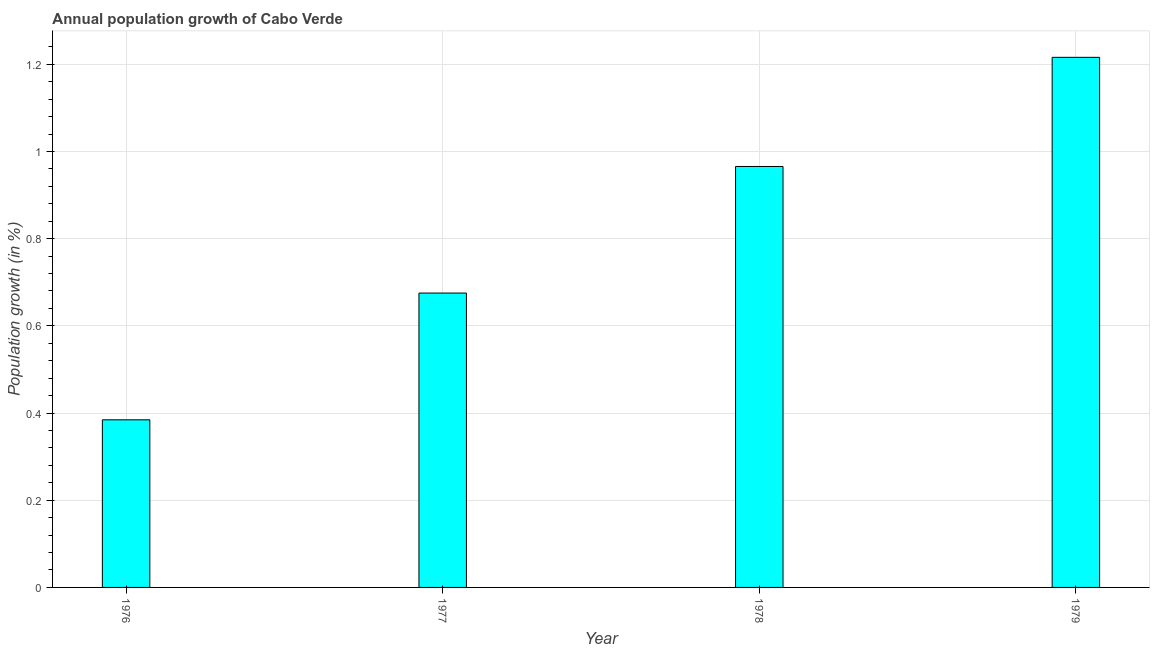Does the graph contain grids?
Offer a terse response. Yes. What is the title of the graph?
Your answer should be compact. Annual population growth of Cabo Verde. What is the label or title of the Y-axis?
Your answer should be very brief. Population growth (in %). What is the population growth in 1979?
Offer a terse response. 1.22. Across all years, what is the maximum population growth?
Provide a short and direct response. 1.22. Across all years, what is the minimum population growth?
Provide a short and direct response. 0.38. In which year was the population growth maximum?
Your answer should be compact. 1979. In which year was the population growth minimum?
Provide a succinct answer. 1976. What is the sum of the population growth?
Keep it short and to the point. 3.24. What is the difference between the population growth in 1976 and 1978?
Your answer should be compact. -0.58. What is the average population growth per year?
Your response must be concise. 0.81. What is the median population growth?
Your answer should be compact. 0.82. In how many years, is the population growth greater than 0.24 %?
Offer a terse response. 4. What is the ratio of the population growth in 1977 to that in 1979?
Keep it short and to the point. 0.56. Is the difference between the population growth in 1978 and 1979 greater than the difference between any two years?
Give a very brief answer. No. Is the sum of the population growth in 1978 and 1979 greater than the maximum population growth across all years?
Offer a terse response. Yes. What is the difference between the highest and the lowest population growth?
Keep it short and to the point. 0.83. In how many years, is the population growth greater than the average population growth taken over all years?
Provide a short and direct response. 2. How many bars are there?
Your answer should be very brief. 4. How many years are there in the graph?
Provide a succinct answer. 4. What is the Population growth (in %) of 1976?
Your answer should be compact. 0.38. What is the Population growth (in %) of 1977?
Provide a short and direct response. 0.68. What is the Population growth (in %) in 1978?
Your answer should be compact. 0.97. What is the Population growth (in %) in 1979?
Provide a succinct answer. 1.22. What is the difference between the Population growth (in %) in 1976 and 1977?
Offer a terse response. -0.29. What is the difference between the Population growth (in %) in 1976 and 1978?
Offer a terse response. -0.58. What is the difference between the Population growth (in %) in 1976 and 1979?
Your answer should be very brief. -0.83. What is the difference between the Population growth (in %) in 1977 and 1978?
Your answer should be very brief. -0.29. What is the difference between the Population growth (in %) in 1977 and 1979?
Ensure brevity in your answer.  -0.54. What is the difference between the Population growth (in %) in 1978 and 1979?
Provide a succinct answer. -0.25. What is the ratio of the Population growth (in %) in 1976 to that in 1977?
Offer a very short reply. 0.57. What is the ratio of the Population growth (in %) in 1976 to that in 1978?
Your response must be concise. 0.4. What is the ratio of the Population growth (in %) in 1976 to that in 1979?
Ensure brevity in your answer.  0.32. What is the ratio of the Population growth (in %) in 1977 to that in 1978?
Make the answer very short. 0.7. What is the ratio of the Population growth (in %) in 1977 to that in 1979?
Your response must be concise. 0.56. What is the ratio of the Population growth (in %) in 1978 to that in 1979?
Your answer should be compact. 0.79. 